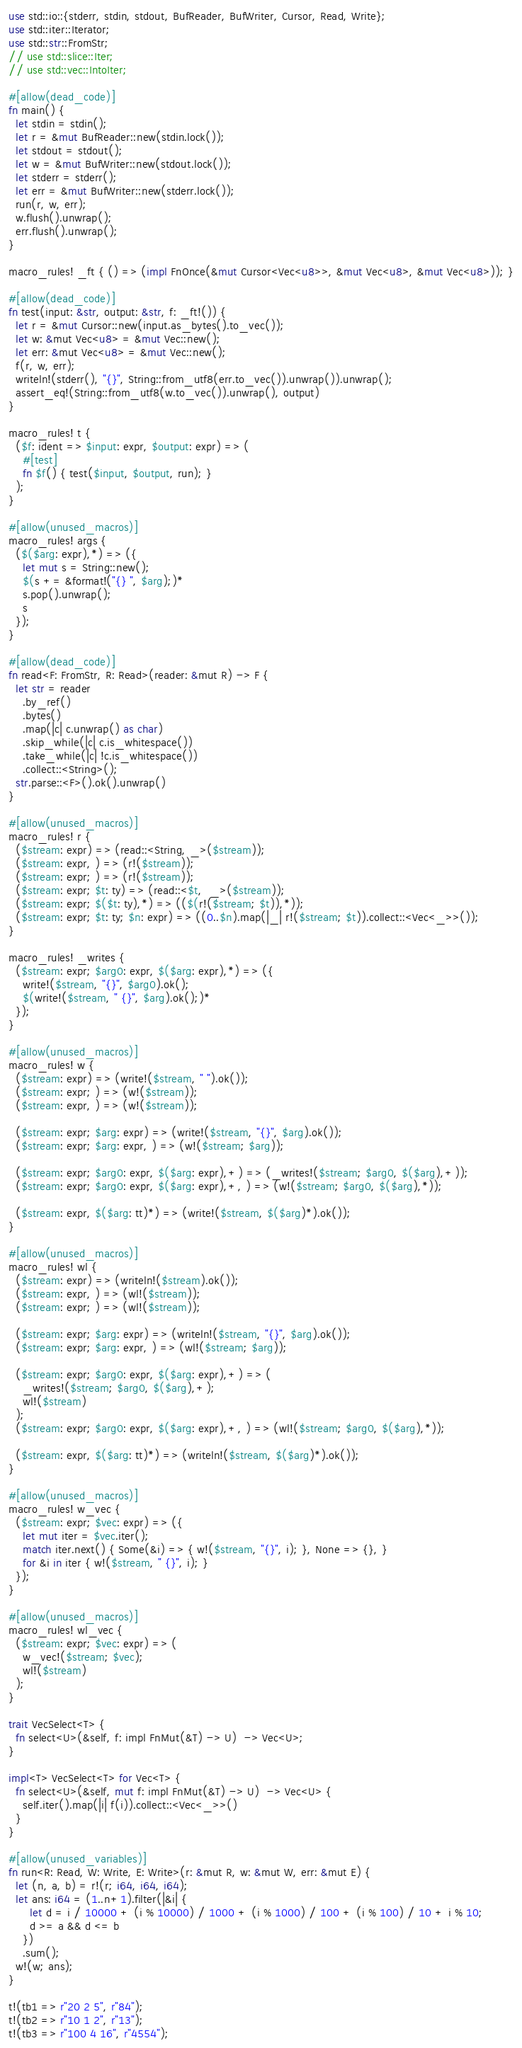<code> <loc_0><loc_0><loc_500><loc_500><_Rust_>use std::io::{stderr, stdin, stdout, BufReader, BufWriter, Cursor, Read, Write};
use std::iter::Iterator;
use std::str::FromStr;
// use std::slice::Iter;
// use std::vec::IntoIter;

#[allow(dead_code)]
fn main() {
  let stdin = stdin();
  let r = &mut BufReader::new(stdin.lock());
  let stdout = stdout();
  let w = &mut BufWriter::new(stdout.lock());
  let stderr = stderr();
  let err = &mut BufWriter::new(stderr.lock());
  run(r, w, err);
  w.flush().unwrap();
  err.flush().unwrap();
}

macro_rules! _ft { () => (impl FnOnce(&mut Cursor<Vec<u8>>, &mut Vec<u8>, &mut Vec<u8>)); }

#[allow(dead_code)]
fn test(input: &str, output: &str, f: _ft!()) {
  let r = &mut Cursor::new(input.as_bytes().to_vec());
  let w: &mut Vec<u8> = &mut Vec::new();
  let err: &mut Vec<u8> = &mut Vec::new();
  f(r, w, err);
  writeln!(stderr(), "{}", String::from_utf8(err.to_vec()).unwrap()).unwrap();
  assert_eq!(String::from_utf8(w.to_vec()).unwrap(), output)
}

macro_rules! t {
  ($f: ident => $input: expr, $output: expr) => (
    #[test]
    fn $f() { test($input, $output, run); }
  );
}

#[allow(unused_macros)]
macro_rules! args {
  ($($arg: expr),*) => ({
    let mut s = String::new();
    $(s += &format!("{} ", $arg);)*
    s.pop().unwrap();
    s
  });
}

#[allow(dead_code)]
fn read<F: FromStr, R: Read>(reader: &mut R) -> F {
  let str = reader
    .by_ref()
    .bytes()
    .map(|c| c.unwrap() as char)
    .skip_while(|c| c.is_whitespace())
    .take_while(|c| !c.is_whitespace())
    .collect::<String>();
  str.parse::<F>().ok().unwrap()
}

#[allow(unused_macros)]
macro_rules! r {
  ($stream: expr) => (read::<String, _>($stream));
  ($stream: expr, ) => (r!($stream));
  ($stream: expr; ) => (r!($stream));
  ($stream: expr; $t: ty) => (read::<$t,  _>($stream));
  ($stream: expr; $($t: ty),*) => (($(r!($stream; $t)),*));
  ($stream: expr; $t: ty; $n: expr) => ((0..$n).map(|_| r!($stream; $t)).collect::<Vec<_>>());
}

macro_rules! _writes {
  ($stream: expr; $arg0: expr, $($arg: expr),*) => ({
    write!($stream, "{}", $arg0).ok();
    $(write!($stream, " {}", $arg).ok();)*
  });
}

#[allow(unused_macros)]
macro_rules! w {
  ($stream: expr) => (write!($stream, " ").ok());
  ($stream: expr; ) => (w!($stream));
  ($stream: expr, ) => (w!($stream));

  ($stream: expr; $arg: expr) => (write!($stream, "{}", $arg).ok());
  ($stream: expr; $arg: expr, ) => (w!($stream; $arg));

  ($stream: expr; $arg0: expr, $($arg: expr),+) => (_writes!($stream; $arg0, $($arg),+));
  ($stream: expr; $arg0: expr, $($arg: expr),+, ) => (w!($stream; $arg0, $($arg),*));

  ($stream: expr, $($arg: tt)*) => (write!($stream, $($arg)*).ok());
}

#[allow(unused_macros)]
macro_rules! wl {
  ($stream: expr) => (writeln!($stream).ok());
  ($stream: expr, ) => (wl!($stream));
  ($stream: expr; ) => (wl!($stream));

  ($stream: expr; $arg: expr) => (writeln!($stream, "{}", $arg).ok());
  ($stream: expr; $arg: expr, ) => (wl!($stream; $arg));

  ($stream: expr; $arg0: expr, $($arg: expr),+) => (
    _writes!($stream; $arg0, $($arg),+);
    wl!($stream)
  );
  ($stream: expr; $arg0: expr, $($arg: expr),+, ) => (wl!($stream; $arg0, $($arg),*));

  ($stream: expr, $($arg: tt)*) => (writeln!($stream, $($arg)*).ok());
}

#[allow(unused_macros)]
macro_rules! w_vec {
  ($stream: expr; $vec: expr) => ({
    let mut iter = $vec.iter();
    match iter.next() { Some(&i) => { w!($stream, "{}", i); }, None => {}, }
    for &i in iter { w!($stream, " {}", i); }
  });
}

#[allow(unused_macros)]
macro_rules! wl_vec {
  ($stream: expr; $vec: expr) => (
    w_vec!($stream; $vec);
    wl!($stream)
  );
}

trait VecSelect<T> {
  fn select<U>(&self, f: impl FnMut(&T) -> U)  -> Vec<U>;
}

impl<T> VecSelect<T> for Vec<T> {
  fn select<U>(&self, mut f: impl FnMut(&T) -> U)  -> Vec<U> {
    self.iter().map(|i| f(i)).collect::<Vec<_>>()
  }
}

#[allow(unused_variables)]
fn run<R: Read, W: Write, E: Write>(r: &mut R, w: &mut W, err: &mut E) {
  let (n, a, b) = r!(r; i64, i64, i64);
  let ans: i64 = (1..n+1).filter(|&i| {
      let d = i / 10000 + (i % 10000) / 1000 + (i % 1000) / 100 + (i % 100) / 10 + i % 10;
      d >= a && d <= b
    })
    .sum();
  w!(w; ans);
}

t!(tb1 => r"20 2 5", r"84");
t!(tb2 => r"10 1 2", r"13");
t!(tb3 => r"100 4 16", r"4554");
</code> 